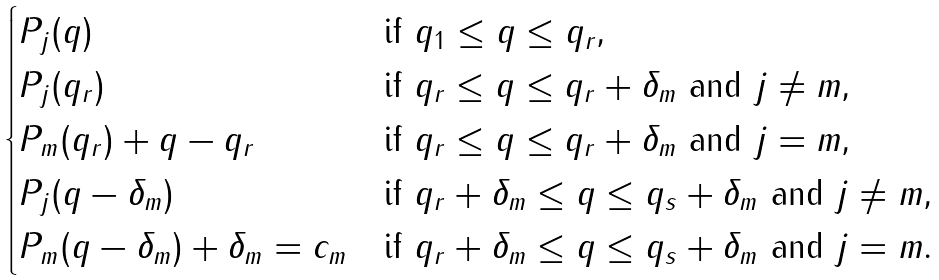Convert formula to latex. <formula><loc_0><loc_0><loc_500><loc_500>\begin{cases} P _ { j } ( q ) & \text {if $q_{1}\leq q\leq q_{r}$,} \\ P _ { j } ( q _ { r } ) & \text {if $q_{r}\leq q\leq q_{r}+\delta_{m}$ and $j\neq m$,} \\ P _ { m } ( q _ { r } ) + q - q _ { r } & \text {if $q_{r}\leq q\leq q_{r}+\delta_{m}$ and $j=m$,} \\ P _ { j } ( q - \delta _ { m } ) & \text {if $q_{r}+\delta_{m}\leq q \leq q_{s}+\delta_{m}$ and $j\neq m$,} \\ P _ { m } ( q - \delta _ { m } ) + \delta _ { m } = c _ { m } & \text {if $q_{r}+\delta_{m}\leq q \leq q_{s}+\delta_{m}$ and $j=m$.} \end{cases}</formula> 